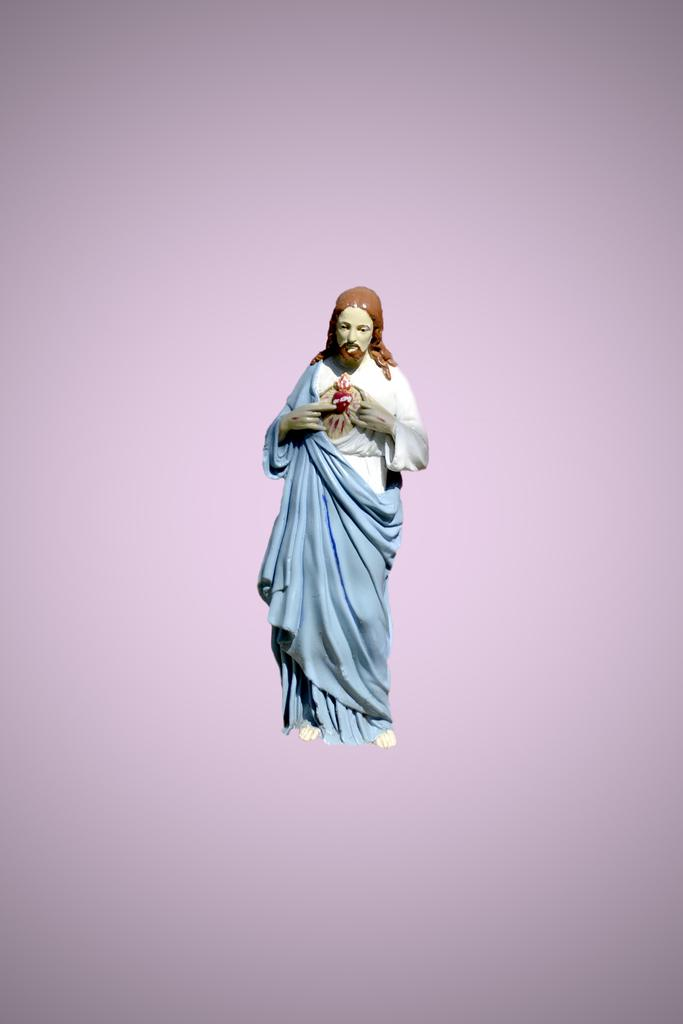What is the main subject in the foreground of the image? There is a sculpture in the foreground of the image. What color is the background of the image? The background of the image is lilac. Can you see an airplane flying in the background of the image? There is no airplane visible in the image; the background is lilac. Is there a bear standing next to the sculpture in the foreground? There is no bear present in the image; only the sculpture is visible in the foreground. 